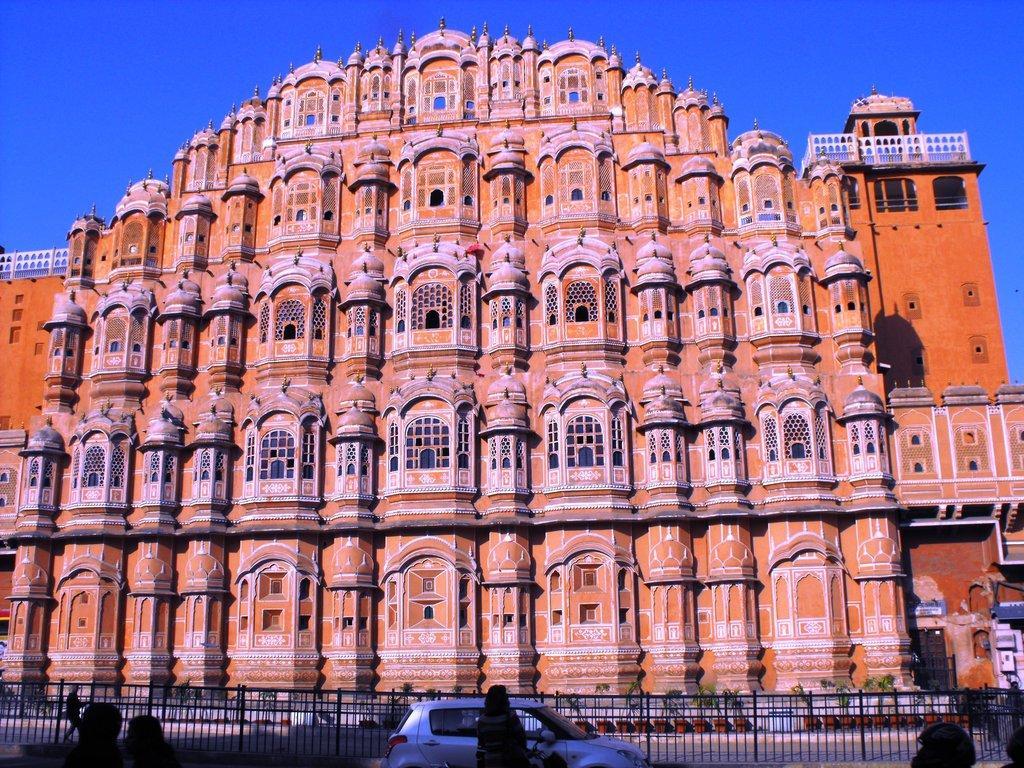Please provide a concise description of this image. In this image we can see a building, there are windows, there is a car travelling on the road, there are group of persons standing, there is a fencing, there are flower pots, there is sky at the top. 